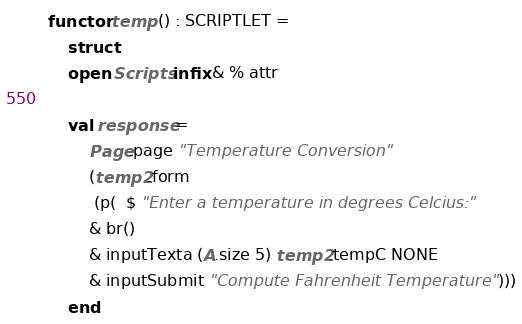Convert code to text. <code><loc_0><loc_0><loc_500><loc_500><_SML_>functor temp () : SCRIPTLET =
    struct
	open Scripts infix & % attr

	val response = 
	    Page.page "Temperature Conversion" 
	    (temp2.form 
	     (p(  $ "Enter a temperature in degrees Celcius:"
		& br()
		& inputTexta (A.size 5) temp2.tempC NONE
		& inputSubmit "Compute Fahrenheit Temperature")))
    end
</code> 